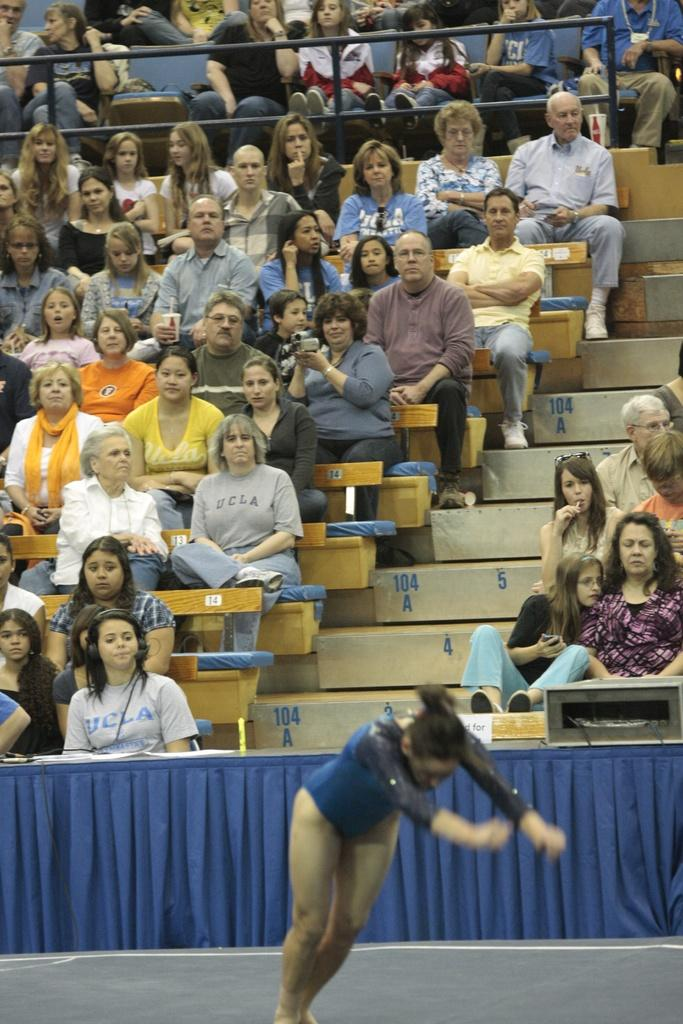Who is the main subject in the image? There is a woman in the image. Where is the woman positioned in relation to the other people? The woman is standing in the front. What is the woman wearing? The woman is wearing a swimming costume. What are the other people in the image doing? The people are sitting on benches and looking in the front. What type of cast can be seen on the woman's arm in the image? There is no cast visible on the woman's arm in the image. What kind of music is being played in the background of the image? There is no music present in the image. 